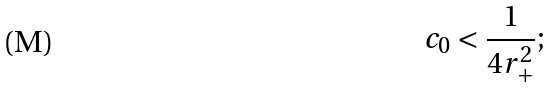<formula> <loc_0><loc_0><loc_500><loc_500>c _ { 0 } < \frac { 1 } { 4 r _ { + } ^ { 2 } } ;</formula> 